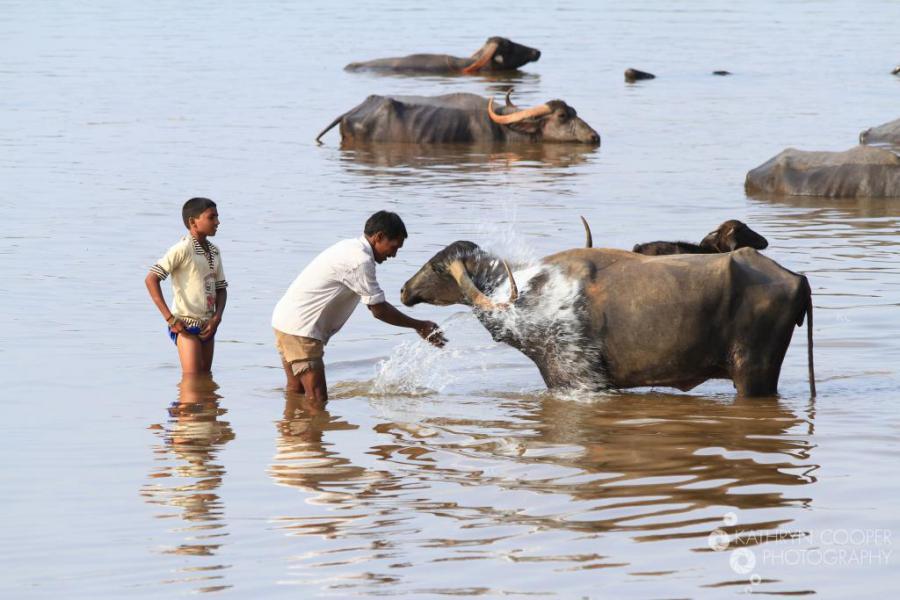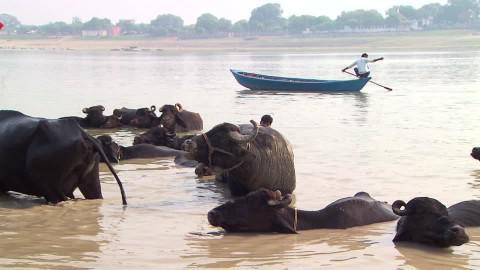The first image is the image on the left, the second image is the image on the right. For the images shown, is this caption "One image shows a shirtless male standing in water and holding a hand toward a water buffalo in water to its neck." true? Answer yes or no. No. The first image is the image on the left, the second image is the image on the right. Given the left and right images, does the statement "The right image contains no more than one water buffalo." hold true? Answer yes or no. No. 